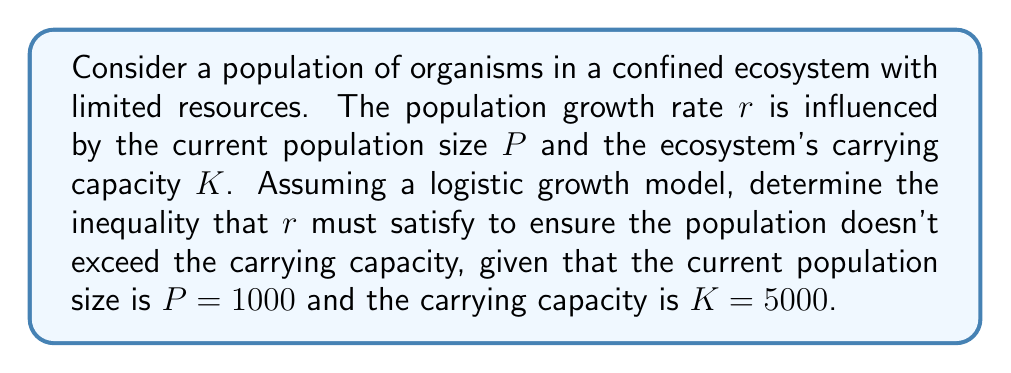Could you help me with this problem? To solve this problem, we'll use the logistic growth model and follow these steps:

1) The logistic growth model is given by the differential equation:

   $$\frac{dP}{dt} = rP(1 - \frac{P}{K})$$

   where $\frac{dP}{dt}$ represents the rate of change of the population.

2) For the population to not exceed the carrying capacity, we need:

   $$\frac{dP}{dt} \leq 0$$

   This ensures that the population growth rate is non-positive when $P = K$.

3) Substituting this condition into our logistic growth equation:

   $$rP(1 - \frac{P}{K}) \leq 0$$

4) We know that $P = 1000$ and $K = 5000$. Let's substitute these values:

   $$r \cdot 1000 \cdot (1 - \frac{1000}{5000}) \leq 0$$

5) Simplify:

   $$r \cdot 1000 \cdot (1 - 0.2) \leq 0$$
   $$r \cdot 1000 \cdot 0.8 \leq 0$$

6) Divide both sides by $1000 \cdot 0.8$ (note that this doesn't change the inequality direction as it's positive):

   $$r \leq 0$$

Therefore, to ensure the population doesn't exceed the carrying capacity, the growth rate $r$ must be non-positive.
Answer: $r \leq 0$ 